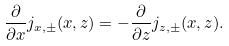<formula> <loc_0><loc_0><loc_500><loc_500>\frac { \partial } { \partial x } j _ { x , \pm } ( x , z ) = - \frac { \partial } { \partial z } j _ { z , \pm } ( x , z ) .</formula> 